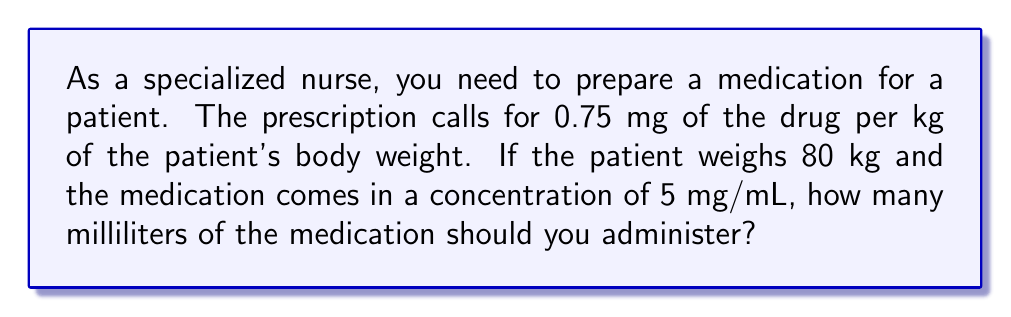Teach me how to tackle this problem. Let's break this down step-by-step:

1. Calculate the total amount of drug needed:
   - Patient weight: 80 kg
   - Dosage: 0.75 mg/kg
   - Total drug needed: $80 \times 0.75 = 60$ mg

2. Convert the drug concentration to a fraction:
   - Concentration: 5 mg/mL = $\frac{5 \text{ mg}}{1 \text{ mL}}$

3. Set up a proportion to find the volume needed:
   $$\frac{5 \text{ mg}}{1 \text{ mL}} = \frac{60 \text{ mg}}{x \text{ mL}}$$

4. Cross multiply:
   $$5x = 60$$

5. Solve for x:
   $$x = \frac{60}{5} = 12$$

Therefore, you need to administer 12 mL of the medication.
Answer: 12 mL 